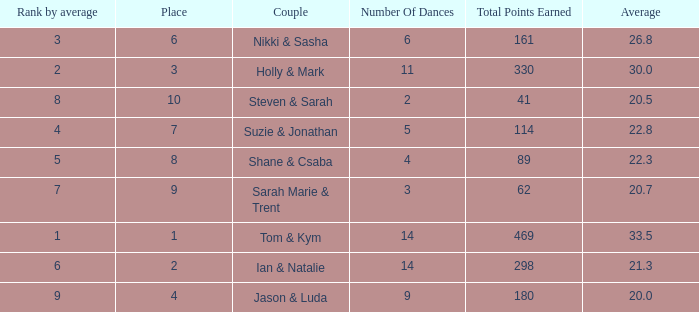What is the number of dances total number if the average is 22.3? 1.0. 